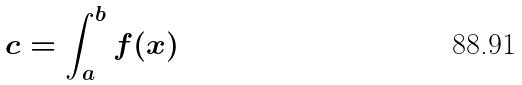Convert formula to latex. <formula><loc_0><loc_0><loc_500><loc_500>c = \int _ { a } ^ { b } f ( x )</formula> 